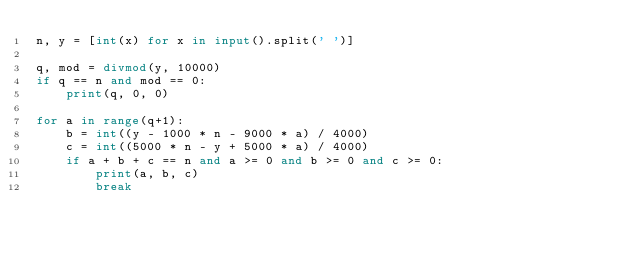Convert code to text. <code><loc_0><loc_0><loc_500><loc_500><_Python_>n, y = [int(x) for x in input().split(' ')]

q, mod = divmod(y, 10000)
if q == n and mod == 0:
    print(q, 0, 0)

for a in range(q+1):
    b = int((y - 1000 * n - 9000 * a) / 4000)
    c = int((5000 * n - y + 5000 * a) / 4000)
    if a + b + c == n and a >= 0 and b >= 0 and c >= 0:
        print(a, b, c)
        break
</code> 